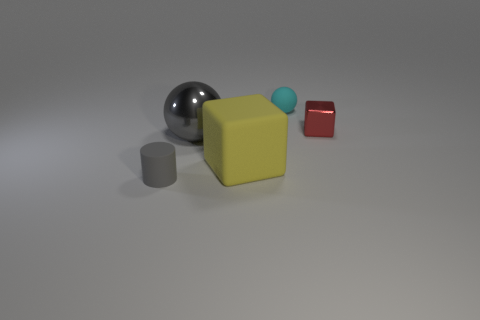Is there a matte cylinder?
Ensure brevity in your answer.  Yes. There is a small object that is in front of the small metallic object; are there any yellow matte objects that are to the left of it?
Make the answer very short. No. There is a big object that is the same shape as the tiny red object; what material is it?
Give a very brief answer. Rubber. Is the number of matte things greater than the number of big spheres?
Offer a very short reply. Yes. Do the rubber cylinder and the block on the right side of the small cyan ball have the same color?
Keep it short and to the point. No. What color is the small thing that is to the right of the tiny cylinder and on the left side of the tiny block?
Offer a very short reply. Cyan. How many other objects are the same material as the yellow thing?
Provide a succinct answer. 2. Are there fewer gray shiny objects than tiny green spheres?
Offer a terse response. No. Do the small ball and the gray object that is behind the cylinder have the same material?
Keep it short and to the point. No. There is a metal thing to the right of the large gray object; what shape is it?
Make the answer very short. Cube. 